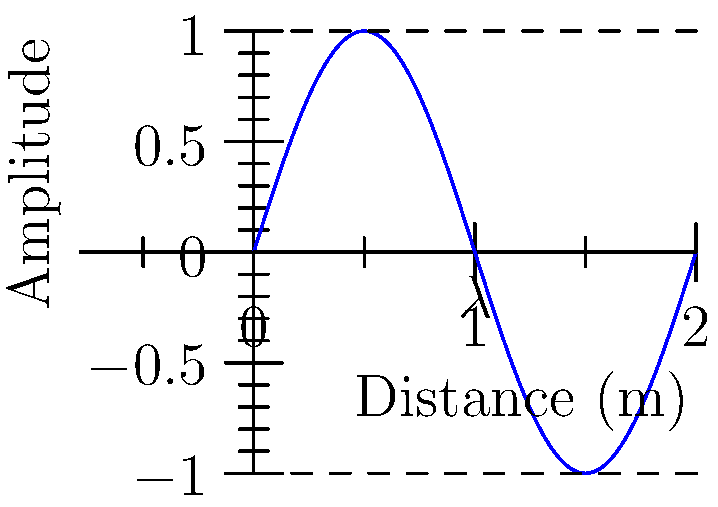In the diagram above, a simple wave is represented. If the wavelength ($\lambda$) shown is 5 meters, what would be the frequency of this wave if it were traveling at the speed of light ($c = 3 \times 10^8$ m/s)? To solve this problem, we'll use the wave equation that relates wavelength ($\lambda$), frequency ($f$), and wave speed ($v$):

$$v = f \lambda$$

We know that:
1. The wave speed ($v$) is the speed of light: $c = 3 \times 10^8$ m/s
2. The wavelength ($\lambda$) is 5 meters

Let's substitute these values into the equation:

$$3 \times 10^8 = f \times 5$$

Now, we can solve for $f$:

$$f = \frac{3 \times 10^8}{5}$$

$$f = 0.6 \times 10^8 \text{ Hz}$$

$$f = 6 \times 10^7 \text{ Hz}$$

Therefore, the frequency of the wave is $6 \times 10^7$ Hz or 60 MHz.
Answer: $6 \times 10^7$ Hz 